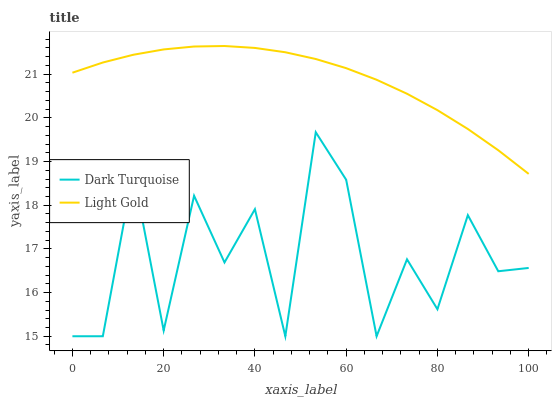Does Dark Turquoise have the minimum area under the curve?
Answer yes or no. Yes. Does Light Gold have the maximum area under the curve?
Answer yes or no. Yes. Does Light Gold have the minimum area under the curve?
Answer yes or no. No. Is Light Gold the smoothest?
Answer yes or no. Yes. Is Dark Turquoise the roughest?
Answer yes or no. Yes. Is Light Gold the roughest?
Answer yes or no. No. Does Dark Turquoise have the lowest value?
Answer yes or no. Yes. Does Light Gold have the lowest value?
Answer yes or no. No. Does Light Gold have the highest value?
Answer yes or no. Yes. Is Dark Turquoise less than Light Gold?
Answer yes or no. Yes. Is Light Gold greater than Dark Turquoise?
Answer yes or no. Yes. Does Dark Turquoise intersect Light Gold?
Answer yes or no. No. 